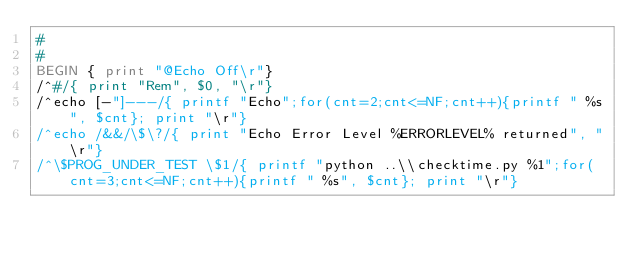<code> <loc_0><loc_0><loc_500><loc_500><_Awk_>#
#
BEGIN { print "@Echo Off\r"}
/^#/{ print "Rem", $0, "\r"}
/^echo [-"]---/{ printf "Echo";for(cnt=2;cnt<=NF;cnt++){printf " %s", $cnt}; print "\r"}
/^echo /&&/\$\?/{ print "Echo Error Level %ERRORLEVEL% returned", "\r"}
/^\$PROG_UNDER_TEST \$1/{ printf "python ..\\checktime.py %1";for(cnt=3;cnt<=NF;cnt++){printf " %s", $cnt}; print "\r"}
</code> 